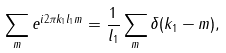<formula> <loc_0><loc_0><loc_500><loc_500>\sum _ { m } e ^ { i 2 \pi k _ { 1 } l _ { 1 } m } = \frac { 1 } { l _ { 1 } } \sum _ { m } \delta ( k _ { 1 } - m ) ,</formula> 